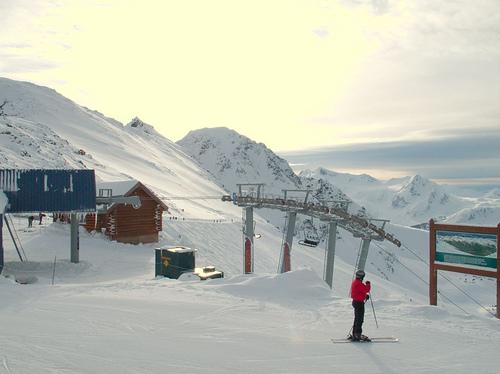Is the sun setting?
Keep it brief. Yes. Are there many people on the ski lift?
Quick response, please. No. Is it cold?
Write a very short answer. Yes. Is it summertime?
Quick response, please. No. How many windows are on the barn?
Quick response, please. 1. Where are the people at?
Quick response, please. Mountain. 